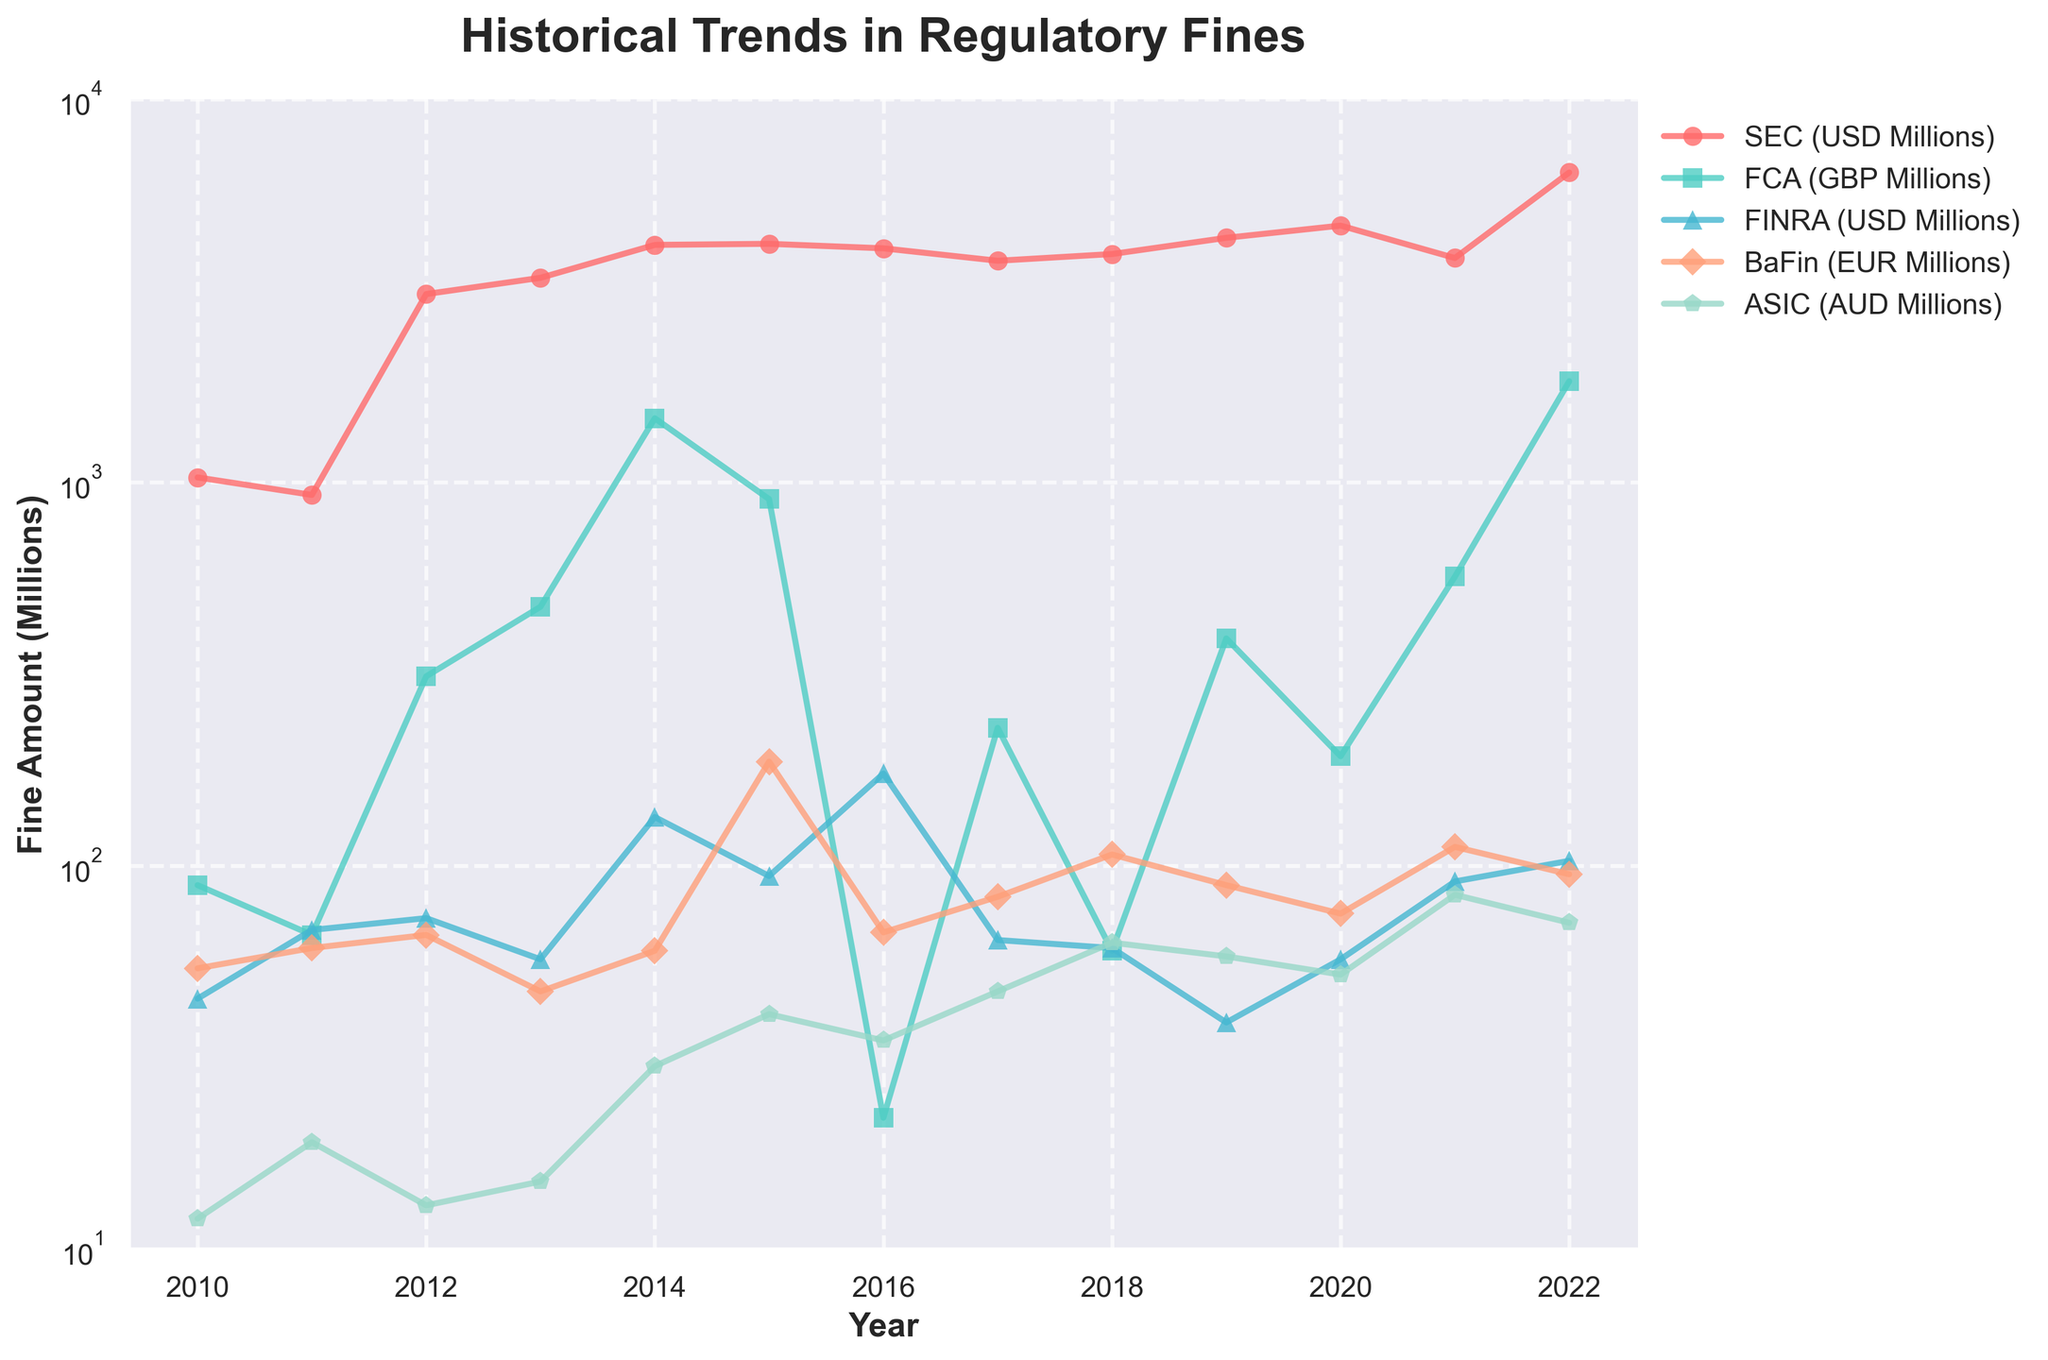Which regulator had the highest fines in 2014? Look at the data points for each regulator in 2014. The SEC had the highest fines at 4168 million USD.
Answer: SEC What was the average fine amount imposed by the BaFin from 2010 to 2022? Add the BaFin fines for each year (54 + 61 + 66 + 47 + 60 + 187 + 67 + 83 + 107 + 89 + 75 + 112 + 95), which sums to 1101. Divide by the number of years (13), resulting in 1101/13.
Answer: 84.69 Which year did the SEC impose fines closest to 4000 million USD? Locate the years in which SEC fines are around 4000 million USD. In 2015, the fines were 4195 million USD.
Answer: 2015 Compare the fines imposed by the FCA and the FDA in 2014. Which was higher and by how much? Look at the fines imposed by the FCA and FCA in 2014. The FCA imposed fines of 1471 million GBP, and the FCA imposed 134 million USD. The FCA fines were higher by (1471 - 134) = 1337 million GBP.
Answer: FCA by 1337 million GBP Which regulator showed the most significant increase in fines from 2021 to 2022? Compare the fine amounts from 2021 to 2022 for each regulator. The SEC increased from 3852 to 6439 million USD, which is an increase of 2587 million USD, the most significant increase.
Answer: SEC Which regulator had the smallest fines in 2010, and what was the amount? Look at the fine amounts for each regulator in 2010. The ASIC had the smallest fines at 12 million AUD.
Answer: ASIC In which year did FINRA impose the highest fines, and what was the amount? Identify the year when FINRA's fines peaked. In 2016, FINRA imposed the highest fines at 174 million USD.
Answer: 2016 What is the trend for the BaFin fines from 2016 to 2019? Observe the values for BaFin fines from 2016 to 2019. They fluctuate starting from 67 in 2016, increasing to 83 in 2017, then rising to 107 in 2018 before decreasing to 89 in 2019.
Answer: Fluctuating How do SEC fines in 2022 compare to the previous year? Compare the SEC fines between 2022 and 2021. In 2022, the fines were 6439 million USD, compared to 3852 million USD in 2021, showing an increase.
Answer: Increased What is the visual color used for SEC on the plot? Identify the color coded for SEC fines in the plot. SEC is represented by the red color on the plot.
Answer: Red 